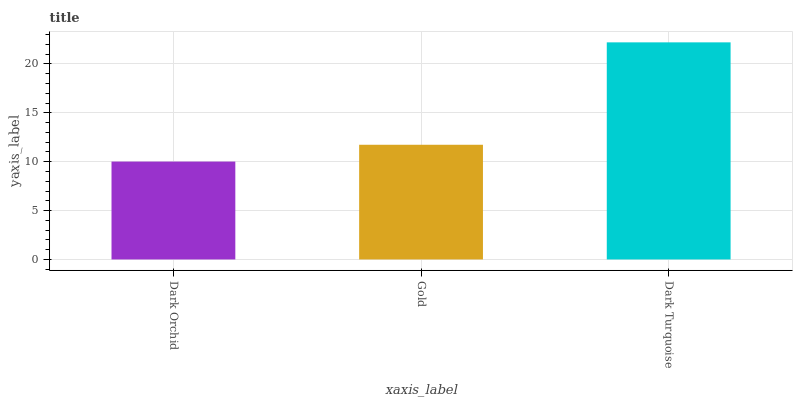Is Dark Orchid the minimum?
Answer yes or no. Yes. Is Dark Turquoise the maximum?
Answer yes or no. Yes. Is Gold the minimum?
Answer yes or no. No. Is Gold the maximum?
Answer yes or no. No. Is Gold greater than Dark Orchid?
Answer yes or no. Yes. Is Dark Orchid less than Gold?
Answer yes or no. Yes. Is Dark Orchid greater than Gold?
Answer yes or no. No. Is Gold less than Dark Orchid?
Answer yes or no. No. Is Gold the high median?
Answer yes or no. Yes. Is Gold the low median?
Answer yes or no. Yes. Is Dark Orchid the high median?
Answer yes or no. No. Is Dark Turquoise the low median?
Answer yes or no. No. 